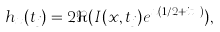<formula> <loc_0><loc_0><loc_500><loc_500>h _ { x } ( t _ { j } ) = 2 \Re ( I ( x , t _ { j } ) e ^ { x ( 1 / 2 + i t _ { j } ) } ) ,</formula> 